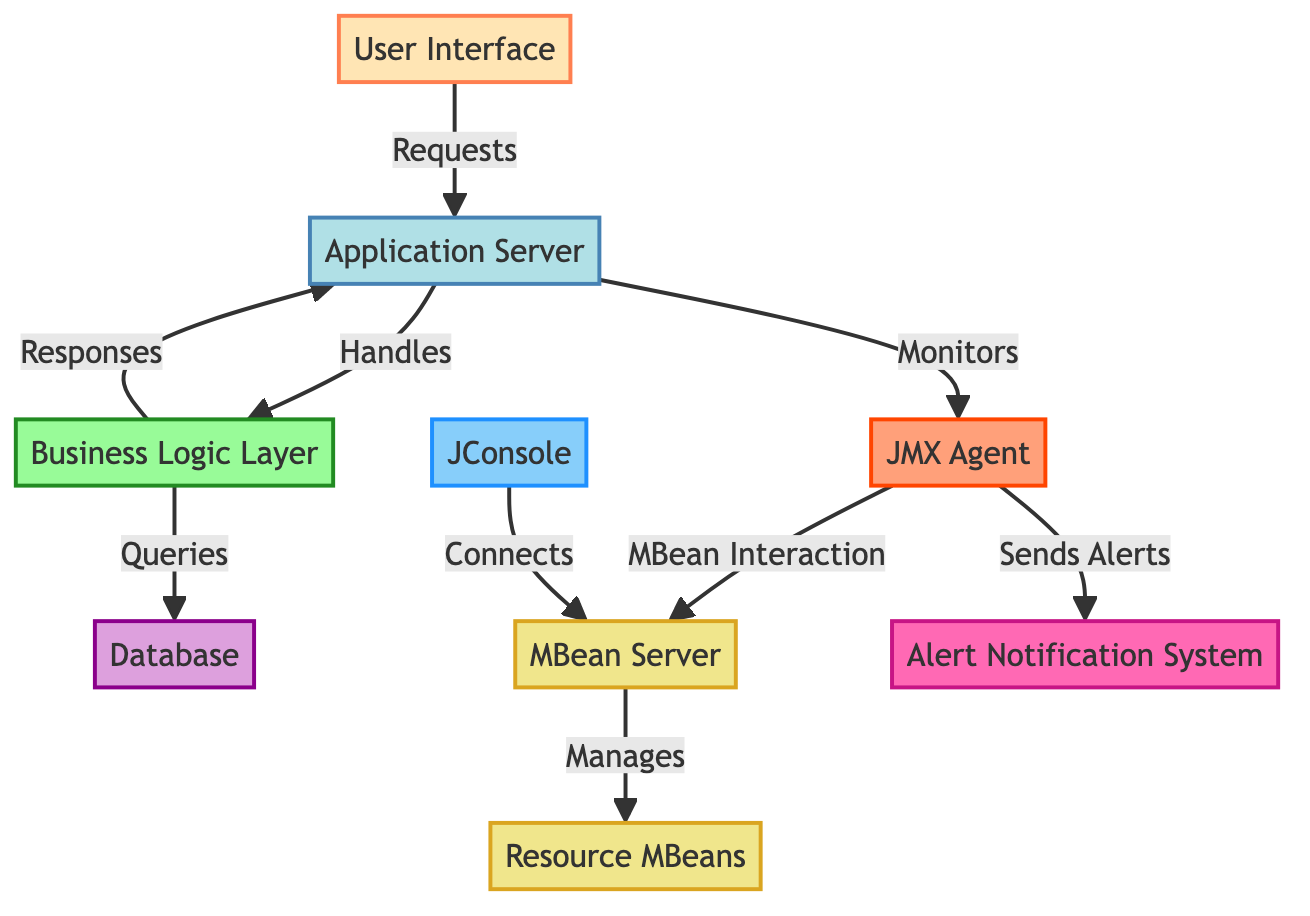What is the total number of nodes in this diagram? To find the total number of nodes, we need to count each labeled box in the diagram. The nodes are: User Interface, Application Server, Business Logic Layer, Database, JMX Agent, MBean Server, Resource MBeans, JConsole, and Alert Notification System. Counting these gives us a total of 9 nodes.
Answer: 9 Which node connects to the Application Server? The node that connects to the Application Server is the User Interface, as indicated by the arrow labeled "Requests" pointing from the User Interface to the Application Server.
Answer: User Interface What is the function of the JMX Agent in this diagram? The JMX Agent interacts with the MBean Server, as shown by the arrow labeled "MBean Interaction" pointing from the JMX Agent to the MBean Server. This indicates that its function is to facilitate communication between the monitoring layer and the MBean Server for resource management.
Answer: MBean Interaction How many edges are present in this diagram? To determine the number of edges, we count every arrow that connects the nodes. The edges represented in the diagram are: User Interface to Application Server (1), Application Server to Business Logic Layer (2), Business Logic Layer to Database (3), Business Logic Layer to Application Server (4), Application Server to JMX Agent (5), JMX Agent to MBean Server (6), MBean Server to Resource MBeans (7), JConsole to MBean Server (8), and JMX Agent to Alert Notification System (9). This totals to 9 edges.
Answer: 9 Which component sends alerts in this system? In the diagram, the JMX Agent sends alerts, which is indicated by the arrow labeled "Sends Alerts" pointing from the JMX Agent to the Alert Notification System.
Answer: JMX Agent What layer handles requests after the User Interface? The layer that handles requests after the User Interface is the Application Server, as clearly indicated by the “Requests” labeled arrow going from the User Interface to the Application Server.
Answer: Application Server What type of resource management does the MBean Server manage? The MBean Server manages Resource MBeans, which is shown by the arrow labeled "Manages" pointing from MBean Server to Resource MBeans in the diagram.
Answer: Resource MBeans Which tool connects to the MBean Server? The tool that connects to the MBean Server is JConsole, as shown by the arrow labeled "Connects" pointing from JConsole to the MBean Server.
Answer: JConsole What does the Business Logic Layer query? The Business Logic Layer queries the Database, which is illustrated by the arrow labeled "Queries" pointing from the Business Logic Layer to the Database.
Answer: Database 